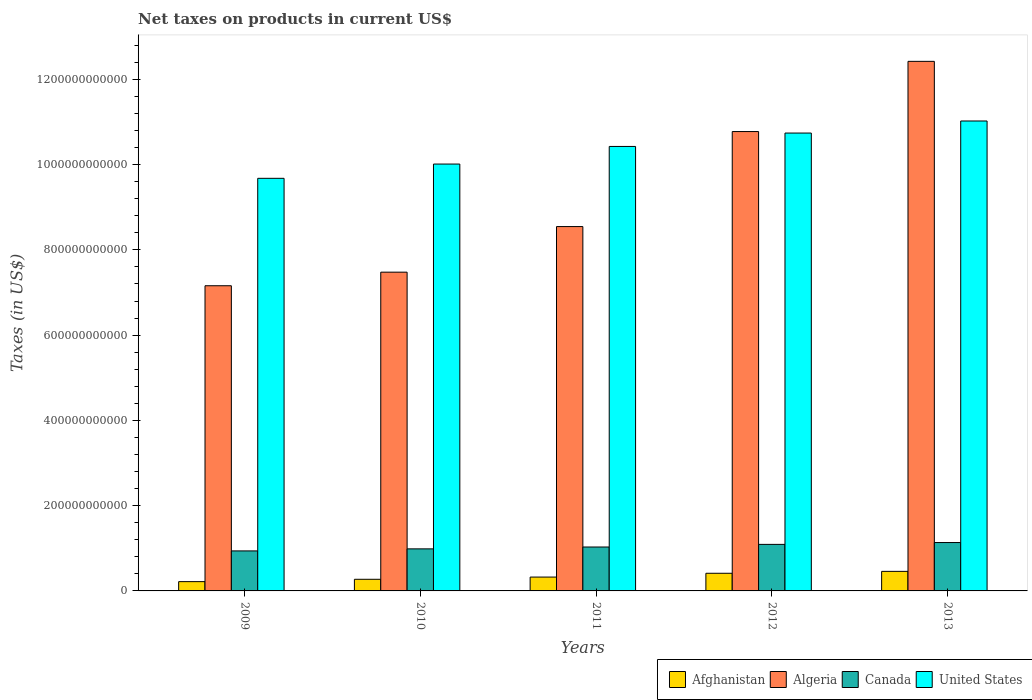How many different coloured bars are there?
Your response must be concise. 4. Are the number of bars per tick equal to the number of legend labels?
Ensure brevity in your answer.  Yes. Are the number of bars on each tick of the X-axis equal?
Give a very brief answer. Yes. How many bars are there on the 1st tick from the right?
Your response must be concise. 4. What is the label of the 3rd group of bars from the left?
Give a very brief answer. 2011. What is the net taxes on products in Canada in 2009?
Ensure brevity in your answer.  9.38e+1. Across all years, what is the maximum net taxes on products in Canada?
Your response must be concise. 1.13e+11. Across all years, what is the minimum net taxes on products in Canada?
Make the answer very short. 9.38e+1. In which year was the net taxes on products in Algeria maximum?
Provide a short and direct response. 2013. In which year was the net taxes on products in United States minimum?
Ensure brevity in your answer.  2009. What is the total net taxes on products in Afghanistan in the graph?
Make the answer very short. 1.69e+11. What is the difference between the net taxes on products in United States in 2010 and that in 2011?
Provide a short and direct response. -4.13e+1. What is the difference between the net taxes on products in Algeria in 2010 and the net taxes on products in Afghanistan in 2009?
Make the answer very short. 7.26e+11. What is the average net taxes on products in Canada per year?
Provide a succinct answer. 1.04e+11. In the year 2009, what is the difference between the net taxes on products in Afghanistan and net taxes on products in United States?
Provide a succinct answer. -9.46e+11. In how many years, is the net taxes on products in Algeria greater than 160000000000 US$?
Offer a very short reply. 5. What is the ratio of the net taxes on products in Afghanistan in 2009 to that in 2010?
Keep it short and to the point. 0.8. Is the net taxes on products in Canada in 2009 less than that in 2013?
Make the answer very short. Yes. Is the difference between the net taxes on products in Afghanistan in 2011 and 2012 greater than the difference between the net taxes on products in United States in 2011 and 2012?
Offer a very short reply. Yes. What is the difference between the highest and the second highest net taxes on products in United States?
Ensure brevity in your answer.  2.83e+1. What is the difference between the highest and the lowest net taxes on products in Algeria?
Provide a succinct answer. 5.26e+11. In how many years, is the net taxes on products in Canada greater than the average net taxes on products in Canada taken over all years?
Ensure brevity in your answer.  2. What does the 3rd bar from the right in 2012 represents?
Offer a very short reply. Algeria. Is it the case that in every year, the sum of the net taxes on products in United States and net taxes on products in Canada is greater than the net taxes on products in Afghanistan?
Make the answer very short. Yes. How many bars are there?
Your response must be concise. 20. How many years are there in the graph?
Offer a very short reply. 5. What is the difference between two consecutive major ticks on the Y-axis?
Offer a very short reply. 2.00e+11. Are the values on the major ticks of Y-axis written in scientific E-notation?
Your answer should be very brief. No. Does the graph contain any zero values?
Ensure brevity in your answer.  No. How many legend labels are there?
Provide a succinct answer. 4. What is the title of the graph?
Your answer should be compact. Net taxes on products in current US$. What is the label or title of the X-axis?
Your answer should be very brief. Years. What is the label or title of the Y-axis?
Keep it short and to the point. Taxes (in US$). What is the Taxes (in US$) of Afghanistan in 2009?
Your response must be concise. 2.18e+1. What is the Taxes (in US$) of Algeria in 2009?
Your response must be concise. 7.16e+11. What is the Taxes (in US$) of Canada in 2009?
Offer a terse response. 9.38e+1. What is the Taxes (in US$) of United States in 2009?
Keep it short and to the point. 9.68e+11. What is the Taxes (in US$) in Afghanistan in 2010?
Offer a very short reply. 2.73e+1. What is the Taxes (in US$) in Algeria in 2010?
Provide a succinct answer. 7.48e+11. What is the Taxes (in US$) in Canada in 2010?
Ensure brevity in your answer.  9.87e+1. What is the Taxes (in US$) in United States in 2010?
Give a very brief answer. 1.00e+12. What is the Taxes (in US$) in Afghanistan in 2011?
Your answer should be compact. 3.25e+1. What is the Taxes (in US$) of Algeria in 2011?
Ensure brevity in your answer.  8.55e+11. What is the Taxes (in US$) in Canada in 2011?
Your response must be concise. 1.03e+11. What is the Taxes (in US$) of United States in 2011?
Ensure brevity in your answer.  1.04e+12. What is the Taxes (in US$) in Afghanistan in 2012?
Offer a very short reply. 4.14e+1. What is the Taxes (in US$) of Algeria in 2012?
Your answer should be compact. 1.08e+12. What is the Taxes (in US$) in Canada in 2012?
Your answer should be very brief. 1.09e+11. What is the Taxes (in US$) of United States in 2012?
Give a very brief answer. 1.07e+12. What is the Taxes (in US$) in Afghanistan in 2013?
Provide a succinct answer. 4.59e+1. What is the Taxes (in US$) of Algeria in 2013?
Offer a very short reply. 1.24e+12. What is the Taxes (in US$) of Canada in 2013?
Make the answer very short. 1.13e+11. What is the Taxes (in US$) of United States in 2013?
Keep it short and to the point. 1.10e+12. Across all years, what is the maximum Taxes (in US$) in Afghanistan?
Your answer should be very brief. 4.59e+1. Across all years, what is the maximum Taxes (in US$) in Algeria?
Offer a very short reply. 1.24e+12. Across all years, what is the maximum Taxes (in US$) of Canada?
Your response must be concise. 1.13e+11. Across all years, what is the maximum Taxes (in US$) in United States?
Your answer should be compact. 1.10e+12. Across all years, what is the minimum Taxes (in US$) in Afghanistan?
Keep it short and to the point. 2.18e+1. Across all years, what is the minimum Taxes (in US$) of Algeria?
Provide a short and direct response. 7.16e+11. Across all years, what is the minimum Taxes (in US$) in Canada?
Your response must be concise. 9.38e+1. Across all years, what is the minimum Taxes (in US$) in United States?
Offer a very short reply. 9.68e+11. What is the total Taxes (in US$) of Afghanistan in the graph?
Your answer should be compact. 1.69e+11. What is the total Taxes (in US$) in Algeria in the graph?
Offer a terse response. 4.64e+12. What is the total Taxes (in US$) in Canada in the graph?
Provide a short and direct response. 5.18e+11. What is the total Taxes (in US$) of United States in the graph?
Keep it short and to the point. 5.19e+12. What is the difference between the Taxes (in US$) of Afghanistan in 2009 and that in 2010?
Give a very brief answer. -5.52e+09. What is the difference between the Taxes (in US$) in Algeria in 2009 and that in 2010?
Offer a very short reply. -3.19e+1. What is the difference between the Taxes (in US$) in Canada in 2009 and that in 2010?
Offer a terse response. -4.83e+09. What is the difference between the Taxes (in US$) of United States in 2009 and that in 2010?
Your answer should be very brief. -3.34e+1. What is the difference between the Taxes (in US$) in Afghanistan in 2009 and that in 2011?
Offer a very short reply. -1.07e+1. What is the difference between the Taxes (in US$) in Algeria in 2009 and that in 2011?
Ensure brevity in your answer.  -1.39e+11. What is the difference between the Taxes (in US$) of Canada in 2009 and that in 2011?
Offer a terse response. -9.18e+09. What is the difference between the Taxes (in US$) of United States in 2009 and that in 2011?
Give a very brief answer. -7.48e+1. What is the difference between the Taxes (in US$) of Afghanistan in 2009 and that in 2012?
Make the answer very short. -1.96e+1. What is the difference between the Taxes (in US$) of Algeria in 2009 and that in 2012?
Keep it short and to the point. -3.62e+11. What is the difference between the Taxes (in US$) of Canada in 2009 and that in 2012?
Your answer should be compact. -1.53e+1. What is the difference between the Taxes (in US$) in United States in 2009 and that in 2012?
Keep it short and to the point. -1.06e+11. What is the difference between the Taxes (in US$) of Afghanistan in 2009 and that in 2013?
Ensure brevity in your answer.  -2.41e+1. What is the difference between the Taxes (in US$) of Algeria in 2009 and that in 2013?
Make the answer very short. -5.26e+11. What is the difference between the Taxes (in US$) of Canada in 2009 and that in 2013?
Give a very brief answer. -1.96e+1. What is the difference between the Taxes (in US$) of United States in 2009 and that in 2013?
Keep it short and to the point. -1.34e+11. What is the difference between the Taxes (in US$) of Afghanistan in 2010 and that in 2011?
Your answer should be compact. -5.18e+09. What is the difference between the Taxes (in US$) in Algeria in 2010 and that in 2011?
Offer a terse response. -1.07e+11. What is the difference between the Taxes (in US$) in Canada in 2010 and that in 2011?
Ensure brevity in your answer.  -4.36e+09. What is the difference between the Taxes (in US$) in United States in 2010 and that in 2011?
Offer a terse response. -4.13e+1. What is the difference between the Taxes (in US$) in Afghanistan in 2010 and that in 2012?
Your answer should be very brief. -1.41e+1. What is the difference between the Taxes (in US$) in Algeria in 2010 and that in 2012?
Offer a terse response. -3.30e+11. What is the difference between the Taxes (in US$) in Canada in 2010 and that in 2012?
Your response must be concise. -1.05e+1. What is the difference between the Taxes (in US$) in United States in 2010 and that in 2012?
Provide a succinct answer. -7.27e+1. What is the difference between the Taxes (in US$) in Afghanistan in 2010 and that in 2013?
Provide a short and direct response. -1.86e+1. What is the difference between the Taxes (in US$) of Algeria in 2010 and that in 2013?
Offer a terse response. -4.94e+11. What is the difference between the Taxes (in US$) of Canada in 2010 and that in 2013?
Ensure brevity in your answer.  -1.48e+1. What is the difference between the Taxes (in US$) in United States in 2010 and that in 2013?
Give a very brief answer. -1.01e+11. What is the difference between the Taxes (in US$) of Afghanistan in 2011 and that in 2012?
Provide a short and direct response. -8.92e+09. What is the difference between the Taxes (in US$) of Algeria in 2011 and that in 2012?
Your answer should be very brief. -2.23e+11. What is the difference between the Taxes (in US$) of Canada in 2011 and that in 2012?
Your response must be concise. -6.14e+09. What is the difference between the Taxes (in US$) in United States in 2011 and that in 2012?
Offer a very short reply. -3.14e+1. What is the difference between the Taxes (in US$) of Afghanistan in 2011 and that in 2013?
Give a very brief answer. -1.34e+1. What is the difference between the Taxes (in US$) in Algeria in 2011 and that in 2013?
Your answer should be compact. -3.88e+11. What is the difference between the Taxes (in US$) of Canada in 2011 and that in 2013?
Make the answer very short. -1.05e+1. What is the difference between the Taxes (in US$) in United States in 2011 and that in 2013?
Keep it short and to the point. -5.97e+1. What is the difference between the Taxes (in US$) of Afghanistan in 2012 and that in 2013?
Offer a terse response. -4.46e+09. What is the difference between the Taxes (in US$) in Algeria in 2012 and that in 2013?
Make the answer very short. -1.65e+11. What is the difference between the Taxes (in US$) in Canada in 2012 and that in 2013?
Give a very brief answer. -4.32e+09. What is the difference between the Taxes (in US$) in United States in 2012 and that in 2013?
Provide a short and direct response. -2.83e+1. What is the difference between the Taxes (in US$) of Afghanistan in 2009 and the Taxes (in US$) of Algeria in 2010?
Give a very brief answer. -7.26e+11. What is the difference between the Taxes (in US$) of Afghanistan in 2009 and the Taxes (in US$) of Canada in 2010?
Your response must be concise. -7.69e+1. What is the difference between the Taxes (in US$) of Afghanistan in 2009 and the Taxes (in US$) of United States in 2010?
Your answer should be compact. -9.79e+11. What is the difference between the Taxes (in US$) in Algeria in 2009 and the Taxes (in US$) in Canada in 2010?
Your answer should be very brief. 6.17e+11. What is the difference between the Taxes (in US$) in Algeria in 2009 and the Taxes (in US$) in United States in 2010?
Make the answer very short. -2.85e+11. What is the difference between the Taxes (in US$) of Canada in 2009 and the Taxes (in US$) of United States in 2010?
Keep it short and to the point. -9.07e+11. What is the difference between the Taxes (in US$) of Afghanistan in 2009 and the Taxes (in US$) of Algeria in 2011?
Provide a short and direct response. -8.33e+11. What is the difference between the Taxes (in US$) in Afghanistan in 2009 and the Taxes (in US$) in Canada in 2011?
Provide a succinct answer. -8.12e+1. What is the difference between the Taxes (in US$) in Afghanistan in 2009 and the Taxes (in US$) in United States in 2011?
Keep it short and to the point. -1.02e+12. What is the difference between the Taxes (in US$) of Algeria in 2009 and the Taxes (in US$) of Canada in 2011?
Your response must be concise. 6.13e+11. What is the difference between the Taxes (in US$) of Algeria in 2009 and the Taxes (in US$) of United States in 2011?
Give a very brief answer. -3.27e+11. What is the difference between the Taxes (in US$) in Canada in 2009 and the Taxes (in US$) in United States in 2011?
Provide a succinct answer. -9.49e+11. What is the difference between the Taxes (in US$) in Afghanistan in 2009 and the Taxes (in US$) in Algeria in 2012?
Provide a succinct answer. -1.06e+12. What is the difference between the Taxes (in US$) of Afghanistan in 2009 and the Taxes (in US$) of Canada in 2012?
Your response must be concise. -8.74e+1. What is the difference between the Taxes (in US$) of Afghanistan in 2009 and the Taxes (in US$) of United States in 2012?
Ensure brevity in your answer.  -1.05e+12. What is the difference between the Taxes (in US$) of Algeria in 2009 and the Taxes (in US$) of Canada in 2012?
Provide a succinct answer. 6.07e+11. What is the difference between the Taxes (in US$) in Algeria in 2009 and the Taxes (in US$) in United States in 2012?
Give a very brief answer. -3.58e+11. What is the difference between the Taxes (in US$) in Canada in 2009 and the Taxes (in US$) in United States in 2012?
Your response must be concise. -9.80e+11. What is the difference between the Taxes (in US$) of Afghanistan in 2009 and the Taxes (in US$) of Algeria in 2013?
Your response must be concise. -1.22e+12. What is the difference between the Taxes (in US$) of Afghanistan in 2009 and the Taxes (in US$) of Canada in 2013?
Provide a short and direct response. -9.17e+1. What is the difference between the Taxes (in US$) in Afghanistan in 2009 and the Taxes (in US$) in United States in 2013?
Offer a terse response. -1.08e+12. What is the difference between the Taxes (in US$) in Algeria in 2009 and the Taxes (in US$) in Canada in 2013?
Provide a succinct answer. 6.02e+11. What is the difference between the Taxes (in US$) of Algeria in 2009 and the Taxes (in US$) of United States in 2013?
Offer a very short reply. -3.86e+11. What is the difference between the Taxes (in US$) of Canada in 2009 and the Taxes (in US$) of United States in 2013?
Your response must be concise. -1.01e+12. What is the difference between the Taxes (in US$) in Afghanistan in 2010 and the Taxes (in US$) in Algeria in 2011?
Provide a short and direct response. -8.27e+11. What is the difference between the Taxes (in US$) of Afghanistan in 2010 and the Taxes (in US$) of Canada in 2011?
Make the answer very short. -7.57e+1. What is the difference between the Taxes (in US$) of Afghanistan in 2010 and the Taxes (in US$) of United States in 2011?
Give a very brief answer. -1.02e+12. What is the difference between the Taxes (in US$) in Algeria in 2010 and the Taxes (in US$) in Canada in 2011?
Ensure brevity in your answer.  6.45e+11. What is the difference between the Taxes (in US$) in Algeria in 2010 and the Taxes (in US$) in United States in 2011?
Keep it short and to the point. -2.95e+11. What is the difference between the Taxes (in US$) in Canada in 2010 and the Taxes (in US$) in United States in 2011?
Give a very brief answer. -9.44e+11. What is the difference between the Taxes (in US$) in Afghanistan in 2010 and the Taxes (in US$) in Algeria in 2012?
Your response must be concise. -1.05e+12. What is the difference between the Taxes (in US$) in Afghanistan in 2010 and the Taxes (in US$) in Canada in 2012?
Give a very brief answer. -8.19e+1. What is the difference between the Taxes (in US$) in Afghanistan in 2010 and the Taxes (in US$) in United States in 2012?
Provide a succinct answer. -1.05e+12. What is the difference between the Taxes (in US$) of Algeria in 2010 and the Taxes (in US$) of Canada in 2012?
Ensure brevity in your answer.  6.39e+11. What is the difference between the Taxes (in US$) of Algeria in 2010 and the Taxes (in US$) of United States in 2012?
Your answer should be very brief. -3.26e+11. What is the difference between the Taxes (in US$) of Canada in 2010 and the Taxes (in US$) of United States in 2012?
Offer a very short reply. -9.75e+11. What is the difference between the Taxes (in US$) of Afghanistan in 2010 and the Taxes (in US$) of Algeria in 2013?
Provide a succinct answer. -1.21e+12. What is the difference between the Taxes (in US$) of Afghanistan in 2010 and the Taxes (in US$) of Canada in 2013?
Provide a succinct answer. -8.62e+1. What is the difference between the Taxes (in US$) in Afghanistan in 2010 and the Taxes (in US$) in United States in 2013?
Offer a terse response. -1.07e+12. What is the difference between the Taxes (in US$) in Algeria in 2010 and the Taxes (in US$) in Canada in 2013?
Keep it short and to the point. 6.34e+11. What is the difference between the Taxes (in US$) in Algeria in 2010 and the Taxes (in US$) in United States in 2013?
Your response must be concise. -3.55e+11. What is the difference between the Taxes (in US$) of Canada in 2010 and the Taxes (in US$) of United States in 2013?
Your answer should be compact. -1.00e+12. What is the difference between the Taxes (in US$) in Afghanistan in 2011 and the Taxes (in US$) in Algeria in 2012?
Offer a terse response. -1.05e+12. What is the difference between the Taxes (in US$) of Afghanistan in 2011 and the Taxes (in US$) of Canada in 2012?
Your response must be concise. -7.67e+1. What is the difference between the Taxes (in US$) of Afghanistan in 2011 and the Taxes (in US$) of United States in 2012?
Your answer should be very brief. -1.04e+12. What is the difference between the Taxes (in US$) in Algeria in 2011 and the Taxes (in US$) in Canada in 2012?
Provide a succinct answer. 7.45e+11. What is the difference between the Taxes (in US$) in Algeria in 2011 and the Taxes (in US$) in United States in 2012?
Offer a terse response. -2.19e+11. What is the difference between the Taxes (in US$) of Canada in 2011 and the Taxes (in US$) of United States in 2012?
Your answer should be compact. -9.71e+11. What is the difference between the Taxes (in US$) in Afghanistan in 2011 and the Taxes (in US$) in Algeria in 2013?
Your answer should be compact. -1.21e+12. What is the difference between the Taxes (in US$) in Afghanistan in 2011 and the Taxes (in US$) in Canada in 2013?
Give a very brief answer. -8.10e+1. What is the difference between the Taxes (in US$) of Afghanistan in 2011 and the Taxes (in US$) of United States in 2013?
Offer a terse response. -1.07e+12. What is the difference between the Taxes (in US$) of Algeria in 2011 and the Taxes (in US$) of Canada in 2013?
Your answer should be very brief. 7.41e+11. What is the difference between the Taxes (in US$) of Algeria in 2011 and the Taxes (in US$) of United States in 2013?
Your answer should be very brief. -2.48e+11. What is the difference between the Taxes (in US$) of Canada in 2011 and the Taxes (in US$) of United States in 2013?
Offer a terse response. -9.99e+11. What is the difference between the Taxes (in US$) of Afghanistan in 2012 and the Taxes (in US$) of Algeria in 2013?
Offer a very short reply. -1.20e+12. What is the difference between the Taxes (in US$) in Afghanistan in 2012 and the Taxes (in US$) in Canada in 2013?
Make the answer very short. -7.21e+1. What is the difference between the Taxes (in US$) in Afghanistan in 2012 and the Taxes (in US$) in United States in 2013?
Provide a short and direct response. -1.06e+12. What is the difference between the Taxes (in US$) of Algeria in 2012 and the Taxes (in US$) of Canada in 2013?
Keep it short and to the point. 9.64e+11. What is the difference between the Taxes (in US$) of Algeria in 2012 and the Taxes (in US$) of United States in 2013?
Your response must be concise. -2.48e+1. What is the difference between the Taxes (in US$) of Canada in 2012 and the Taxes (in US$) of United States in 2013?
Your response must be concise. -9.93e+11. What is the average Taxes (in US$) of Afghanistan per year?
Your response must be concise. 3.38e+1. What is the average Taxes (in US$) of Algeria per year?
Offer a very short reply. 9.28e+11. What is the average Taxes (in US$) in Canada per year?
Provide a short and direct response. 1.04e+11. What is the average Taxes (in US$) in United States per year?
Keep it short and to the point. 1.04e+12. In the year 2009, what is the difference between the Taxes (in US$) in Afghanistan and Taxes (in US$) in Algeria?
Keep it short and to the point. -6.94e+11. In the year 2009, what is the difference between the Taxes (in US$) of Afghanistan and Taxes (in US$) of Canada?
Your response must be concise. -7.20e+1. In the year 2009, what is the difference between the Taxes (in US$) in Afghanistan and Taxes (in US$) in United States?
Your answer should be compact. -9.46e+11. In the year 2009, what is the difference between the Taxes (in US$) in Algeria and Taxes (in US$) in Canada?
Your response must be concise. 6.22e+11. In the year 2009, what is the difference between the Taxes (in US$) in Algeria and Taxes (in US$) in United States?
Offer a very short reply. -2.52e+11. In the year 2009, what is the difference between the Taxes (in US$) in Canada and Taxes (in US$) in United States?
Your response must be concise. -8.74e+11. In the year 2010, what is the difference between the Taxes (in US$) in Afghanistan and Taxes (in US$) in Algeria?
Provide a succinct answer. -7.20e+11. In the year 2010, what is the difference between the Taxes (in US$) in Afghanistan and Taxes (in US$) in Canada?
Keep it short and to the point. -7.14e+1. In the year 2010, what is the difference between the Taxes (in US$) of Afghanistan and Taxes (in US$) of United States?
Keep it short and to the point. -9.74e+11. In the year 2010, what is the difference between the Taxes (in US$) of Algeria and Taxes (in US$) of Canada?
Your answer should be very brief. 6.49e+11. In the year 2010, what is the difference between the Taxes (in US$) of Algeria and Taxes (in US$) of United States?
Your answer should be compact. -2.54e+11. In the year 2010, what is the difference between the Taxes (in US$) in Canada and Taxes (in US$) in United States?
Offer a very short reply. -9.03e+11. In the year 2011, what is the difference between the Taxes (in US$) in Afghanistan and Taxes (in US$) in Algeria?
Your answer should be very brief. -8.22e+11. In the year 2011, what is the difference between the Taxes (in US$) of Afghanistan and Taxes (in US$) of Canada?
Offer a very short reply. -7.05e+1. In the year 2011, what is the difference between the Taxes (in US$) of Afghanistan and Taxes (in US$) of United States?
Offer a very short reply. -1.01e+12. In the year 2011, what is the difference between the Taxes (in US$) of Algeria and Taxes (in US$) of Canada?
Make the answer very short. 7.52e+11. In the year 2011, what is the difference between the Taxes (in US$) in Algeria and Taxes (in US$) in United States?
Your answer should be very brief. -1.88e+11. In the year 2011, what is the difference between the Taxes (in US$) of Canada and Taxes (in US$) of United States?
Make the answer very short. -9.40e+11. In the year 2012, what is the difference between the Taxes (in US$) of Afghanistan and Taxes (in US$) of Algeria?
Provide a succinct answer. -1.04e+12. In the year 2012, what is the difference between the Taxes (in US$) of Afghanistan and Taxes (in US$) of Canada?
Ensure brevity in your answer.  -6.78e+1. In the year 2012, what is the difference between the Taxes (in US$) in Afghanistan and Taxes (in US$) in United States?
Offer a very short reply. -1.03e+12. In the year 2012, what is the difference between the Taxes (in US$) in Algeria and Taxes (in US$) in Canada?
Your answer should be very brief. 9.68e+11. In the year 2012, what is the difference between the Taxes (in US$) of Algeria and Taxes (in US$) of United States?
Provide a short and direct response. 3.52e+09. In the year 2012, what is the difference between the Taxes (in US$) of Canada and Taxes (in US$) of United States?
Keep it short and to the point. -9.65e+11. In the year 2013, what is the difference between the Taxes (in US$) of Afghanistan and Taxes (in US$) of Algeria?
Offer a terse response. -1.20e+12. In the year 2013, what is the difference between the Taxes (in US$) in Afghanistan and Taxes (in US$) in Canada?
Offer a terse response. -6.76e+1. In the year 2013, what is the difference between the Taxes (in US$) in Afghanistan and Taxes (in US$) in United States?
Your answer should be very brief. -1.06e+12. In the year 2013, what is the difference between the Taxes (in US$) of Algeria and Taxes (in US$) of Canada?
Give a very brief answer. 1.13e+12. In the year 2013, what is the difference between the Taxes (in US$) of Algeria and Taxes (in US$) of United States?
Ensure brevity in your answer.  1.40e+11. In the year 2013, what is the difference between the Taxes (in US$) of Canada and Taxes (in US$) of United States?
Offer a terse response. -9.89e+11. What is the ratio of the Taxes (in US$) of Afghanistan in 2009 to that in 2010?
Keep it short and to the point. 0.8. What is the ratio of the Taxes (in US$) of Algeria in 2009 to that in 2010?
Offer a very short reply. 0.96. What is the ratio of the Taxes (in US$) of Canada in 2009 to that in 2010?
Give a very brief answer. 0.95. What is the ratio of the Taxes (in US$) in United States in 2009 to that in 2010?
Your answer should be very brief. 0.97. What is the ratio of the Taxes (in US$) in Afghanistan in 2009 to that in 2011?
Offer a very short reply. 0.67. What is the ratio of the Taxes (in US$) of Algeria in 2009 to that in 2011?
Your answer should be compact. 0.84. What is the ratio of the Taxes (in US$) of Canada in 2009 to that in 2011?
Your answer should be compact. 0.91. What is the ratio of the Taxes (in US$) of United States in 2009 to that in 2011?
Make the answer very short. 0.93. What is the ratio of the Taxes (in US$) of Afghanistan in 2009 to that in 2012?
Your response must be concise. 0.53. What is the ratio of the Taxes (in US$) in Algeria in 2009 to that in 2012?
Give a very brief answer. 0.66. What is the ratio of the Taxes (in US$) of Canada in 2009 to that in 2012?
Provide a succinct answer. 0.86. What is the ratio of the Taxes (in US$) in United States in 2009 to that in 2012?
Provide a short and direct response. 0.9. What is the ratio of the Taxes (in US$) in Afghanistan in 2009 to that in 2013?
Ensure brevity in your answer.  0.47. What is the ratio of the Taxes (in US$) of Algeria in 2009 to that in 2013?
Your response must be concise. 0.58. What is the ratio of the Taxes (in US$) of Canada in 2009 to that in 2013?
Give a very brief answer. 0.83. What is the ratio of the Taxes (in US$) in United States in 2009 to that in 2013?
Your answer should be very brief. 0.88. What is the ratio of the Taxes (in US$) of Afghanistan in 2010 to that in 2011?
Keep it short and to the point. 0.84. What is the ratio of the Taxes (in US$) in Algeria in 2010 to that in 2011?
Give a very brief answer. 0.87. What is the ratio of the Taxes (in US$) in Canada in 2010 to that in 2011?
Make the answer very short. 0.96. What is the ratio of the Taxes (in US$) of United States in 2010 to that in 2011?
Ensure brevity in your answer.  0.96. What is the ratio of the Taxes (in US$) in Afghanistan in 2010 to that in 2012?
Offer a very short reply. 0.66. What is the ratio of the Taxes (in US$) of Algeria in 2010 to that in 2012?
Your answer should be very brief. 0.69. What is the ratio of the Taxes (in US$) of Canada in 2010 to that in 2012?
Your response must be concise. 0.9. What is the ratio of the Taxes (in US$) in United States in 2010 to that in 2012?
Offer a very short reply. 0.93. What is the ratio of the Taxes (in US$) of Afghanistan in 2010 to that in 2013?
Give a very brief answer. 0.6. What is the ratio of the Taxes (in US$) in Algeria in 2010 to that in 2013?
Ensure brevity in your answer.  0.6. What is the ratio of the Taxes (in US$) in Canada in 2010 to that in 2013?
Keep it short and to the point. 0.87. What is the ratio of the Taxes (in US$) in United States in 2010 to that in 2013?
Give a very brief answer. 0.91. What is the ratio of the Taxes (in US$) of Afghanistan in 2011 to that in 2012?
Your answer should be very brief. 0.78. What is the ratio of the Taxes (in US$) of Algeria in 2011 to that in 2012?
Give a very brief answer. 0.79. What is the ratio of the Taxes (in US$) of Canada in 2011 to that in 2012?
Provide a short and direct response. 0.94. What is the ratio of the Taxes (in US$) of United States in 2011 to that in 2012?
Your answer should be compact. 0.97. What is the ratio of the Taxes (in US$) in Afghanistan in 2011 to that in 2013?
Your response must be concise. 0.71. What is the ratio of the Taxes (in US$) of Algeria in 2011 to that in 2013?
Provide a short and direct response. 0.69. What is the ratio of the Taxes (in US$) in Canada in 2011 to that in 2013?
Give a very brief answer. 0.91. What is the ratio of the Taxes (in US$) in United States in 2011 to that in 2013?
Your response must be concise. 0.95. What is the ratio of the Taxes (in US$) in Afghanistan in 2012 to that in 2013?
Offer a very short reply. 0.9. What is the ratio of the Taxes (in US$) in Algeria in 2012 to that in 2013?
Offer a terse response. 0.87. What is the ratio of the Taxes (in US$) in United States in 2012 to that in 2013?
Ensure brevity in your answer.  0.97. What is the difference between the highest and the second highest Taxes (in US$) in Afghanistan?
Provide a succinct answer. 4.46e+09. What is the difference between the highest and the second highest Taxes (in US$) of Algeria?
Give a very brief answer. 1.65e+11. What is the difference between the highest and the second highest Taxes (in US$) of Canada?
Offer a terse response. 4.32e+09. What is the difference between the highest and the second highest Taxes (in US$) in United States?
Keep it short and to the point. 2.83e+1. What is the difference between the highest and the lowest Taxes (in US$) of Afghanistan?
Your answer should be compact. 2.41e+1. What is the difference between the highest and the lowest Taxes (in US$) in Algeria?
Your answer should be very brief. 5.26e+11. What is the difference between the highest and the lowest Taxes (in US$) in Canada?
Offer a terse response. 1.96e+1. What is the difference between the highest and the lowest Taxes (in US$) of United States?
Your response must be concise. 1.34e+11. 